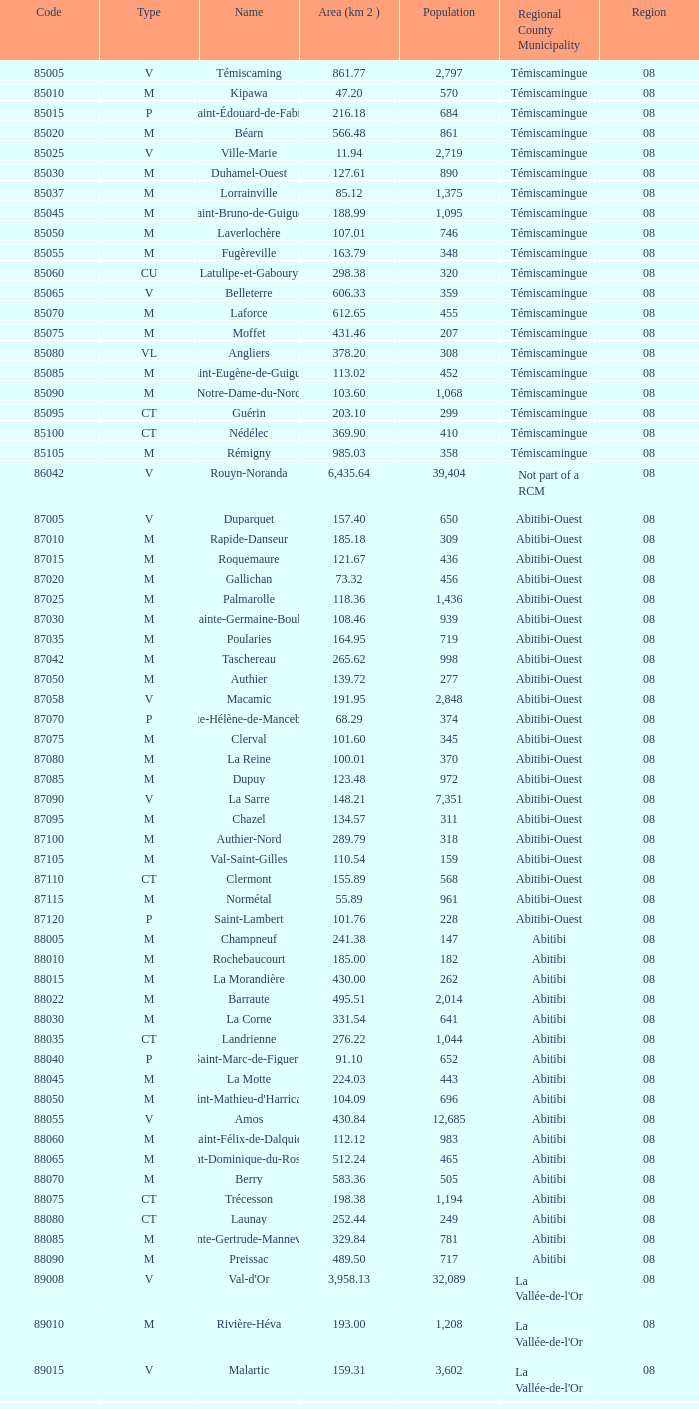What is Dupuy lowest area in km2? 123.48. Write the full table. {'header': ['Code', 'Type', 'Name', 'Area (km 2 )', 'Population', 'Regional County Municipality', 'Region'], 'rows': [['85005', 'V', 'Témiscaming', '861.77', '2,797', 'Témiscamingue', '08'], ['85010', 'M', 'Kipawa', '47.20', '570', 'Témiscamingue', '08'], ['85015', 'P', 'Saint-Édouard-de-Fabre', '216.18', '684', 'Témiscamingue', '08'], ['85020', 'M', 'Béarn', '566.48', '861', 'Témiscamingue', '08'], ['85025', 'V', 'Ville-Marie', '11.94', '2,719', 'Témiscamingue', '08'], ['85030', 'M', 'Duhamel-Ouest', '127.61', '890', 'Témiscamingue', '08'], ['85037', 'M', 'Lorrainville', '85.12', '1,375', 'Témiscamingue', '08'], ['85045', 'M', 'Saint-Bruno-de-Guigues', '188.99', '1,095', 'Témiscamingue', '08'], ['85050', 'M', 'Laverlochère', '107.01', '746', 'Témiscamingue', '08'], ['85055', 'M', 'Fugèreville', '163.79', '348', 'Témiscamingue', '08'], ['85060', 'CU', 'Latulipe-et-Gaboury', '298.38', '320', 'Témiscamingue', '08'], ['85065', 'V', 'Belleterre', '606.33', '359', 'Témiscamingue', '08'], ['85070', 'M', 'Laforce', '612.65', '455', 'Témiscamingue', '08'], ['85075', 'M', 'Moffet', '431.46', '207', 'Témiscamingue', '08'], ['85080', 'VL', 'Angliers', '378.20', '308', 'Témiscamingue', '08'], ['85085', 'M', 'Saint-Eugène-de-Guigues', '113.02', '452', 'Témiscamingue', '08'], ['85090', 'M', 'Notre-Dame-du-Nord', '103.60', '1,068', 'Témiscamingue', '08'], ['85095', 'CT', 'Guérin', '203.10', '299', 'Témiscamingue', '08'], ['85100', 'CT', 'Nédélec', '369.90', '410', 'Témiscamingue', '08'], ['85105', 'M', 'Rémigny', '985.03', '358', 'Témiscamingue', '08'], ['86042', 'V', 'Rouyn-Noranda', '6,435.64', '39,404', 'Not part of a RCM', '08'], ['87005', 'V', 'Duparquet', '157.40', '650', 'Abitibi-Ouest', '08'], ['87010', 'M', 'Rapide-Danseur', '185.18', '309', 'Abitibi-Ouest', '08'], ['87015', 'M', 'Roquemaure', '121.67', '436', 'Abitibi-Ouest', '08'], ['87020', 'M', 'Gallichan', '73.32', '456', 'Abitibi-Ouest', '08'], ['87025', 'M', 'Palmarolle', '118.36', '1,436', 'Abitibi-Ouest', '08'], ['87030', 'M', 'Sainte-Germaine-Boulé', '108.46', '939', 'Abitibi-Ouest', '08'], ['87035', 'M', 'Poularies', '164.95', '719', 'Abitibi-Ouest', '08'], ['87042', 'M', 'Taschereau', '265.62', '998', 'Abitibi-Ouest', '08'], ['87050', 'M', 'Authier', '139.72', '277', 'Abitibi-Ouest', '08'], ['87058', 'V', 'Macamic', '191.95', '2,848', 'Abitibi-Ouest', '08'], ['87070', 'P', 'Sainte-Hélène-de-Mancebourg', '68.29', '374', 'Abitibi-Ouest', '08'], ['87075', 'M', 'Clerval', '101.60', '345', 'Abitibi-Ouest', '08'], ['87080', 'M', 'La Reine', '100.01', '370', 'Abitibi-Ouest', '08'], ['87085', 'M', 'Dupuy', '123.48', '972', 'Abitibi-Ouest', '08'], ['87090', 'V', 'La Sarre', '148.21', '7,351', 'Abitibi-Ouest', '08'], ['87095', 'M', 'Chazel', '134.57', '311', 'Abitibi-Ouest', '08'], ['87100', 'M', 'Authier-Nord', '289.79', '318', 'Abitibi-Ouest', '08'], ['87105', 'M', 'Val-Saint-Gilles', '110.54', '159', 'Abitibi-Ouest', '08'], ['87110', 'CT', 'Clermont', '155.89', '568', 'Abitibi-Ouest', '08'], ['87115', 'M', 'Normétal', '55.89', '961', 'Abitibi-Ouest', '08'], ['87120', 'P', 'Saint-Lambert', '101.76', '228', 'Abitibi-Ouest', '08'], ['88005', 'M', 'Champneuf', '241.38', '147', 'Abitibi', '08'], ['88010', 'M', 'Rochebaucourt', '185.00', '182', 'Abitibi', '08'], ['88015', 'M', 'La Morandière', '430.00', '262', 'Abitibi', '08'], ['88022', 'M', 'Barraute', '495.51', '2,014', 'Abitibi', '08'], ['88030', 'M', 'La Corne', '331.54', '641', 'Abitibi', '08'], ['88035', 'CT', 'Landrienne', '276.22', '1,044', 'Abitibi', '08'], ['88040', 'P', 'Saint-Marc-de-Figuery', '91.10', '652', 'Abitibi', '08'], ['88045', 'M', 'La Motte', '224.03', '443', 'Abitibi', '08'], ['88050', 'M', "Saint-Mathieu-d'Harricana", '104.09', '696', 'Abitibi', '08'], ['88055', 'V', 'Amos', '430.84', '12,685', 'Abitibi', '08'], ['88060', 'M', 'Saint-Félix-de-Dalquier', '112.12', '983', 'Abitibi', '08'], ['88065', 'M', 'Saint-Dominique-du-Rosaire', '512.24', '465', 'Abitibi', '08'], ['88070', 'M', 'Berry', '583.36', '505', 'Abitibi', '08'], ['88075', 'CT', 'Trécesson', '198.38', '1,194', 'Abitibi', '08'], ['88080', 'CT', 'Launay', '252.44', '249', 'Abitibi', '08'], ['88085', 'M', 'Sainte-Gertrude-Manneville', '329.84', '781', 'Abitibi', '08'], ['88090', 'M', 'Preissac', '489.50', '717', 'Abitibi', '08'], ['89008', 'V', "Val-d'Or", '3,958.13', '32,089', "La Vallée-de-l'Or", '08'], ['89010', 'M', 'Rivière-Héva', '193.00', '1,208', "La Vallée-de-l'Or", '08'], ['89015', 'V', 'Malartic', '159.31', '3,602', "La Vallée-de-l'Or", '08'], ['89040', 'V', 'Senneterre', '16,524.89', '3,165', "La Vallée-de-l'Or", '08'], ['89045', 'P', 'Senneterre', '432.98', '1,146', "La Vallée-de-l'Or", '08'], ['89050', 'M', 'Belcourt', '411.23', '261', "La Vallée-de-l'Or", '08']]} 